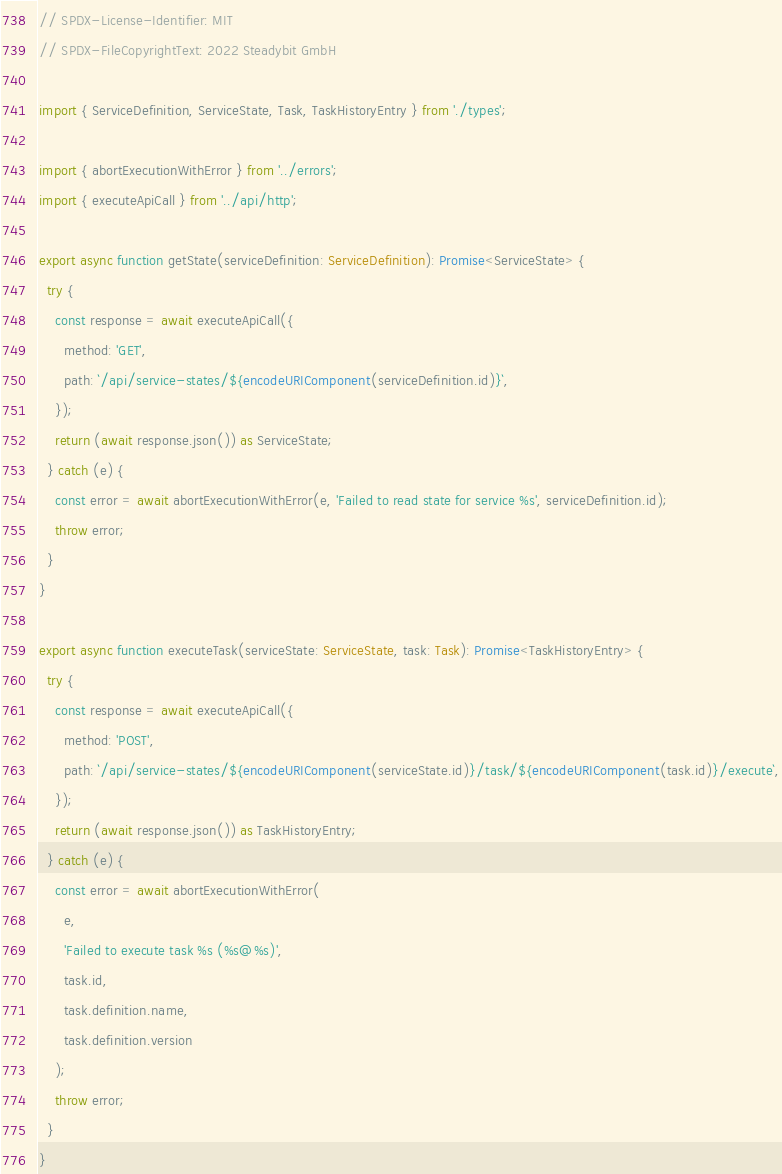<code> <loc_0><loc_0><loc_500><loc_500><_TypeScript_>// SPDX-License-Identifier: MIT
// SPDX-FileCopyrightText: 2022 Steadybit GmbH

import { ServiceDefinition, ServiceState, Task, TaskHistoryEntry } from './types';

import { abortExecutionWithError } from '../errors';
import { executeApiCall } from '../api/http';

export async function getState(serviceDefinition: ServiceDefinition): Promise<ServiceState> {
  try {
    const response = await executeApiCall({
      method: 'GET',
      path: `/api/service-states/${encodeURIComponent(serviceDefinition.id)}`,
    });
    return (await response.json()) as ServiceState;
  } catch (e) {
    const error = await abortExecutionWithError(e, 'Failed to read state for service %s', serviceDefinition.id);
    throw error;
  }
}

export async function executeTask(serviceState: ServiceState, task: Task): Promise<TaskHistoryEntry> {
  try {
    const response = await executeApiCall({
      method: 'POST',
      path: `/api/service-states/${encodeURIComponent(serviceState.id)}/task/${encodeURIComponent(task.id)}/execute`,
    });
    return (await response.json()) as TaskHistoryEntry;
  } catch (e) {
    const error = await abortExecutionWithError(
      e,
      'Failed to execute task %s (%s@%s)',
      task.id,
      task.definition.name,
      task.definition.version
    );
    throw error;
  }
}
</code> 